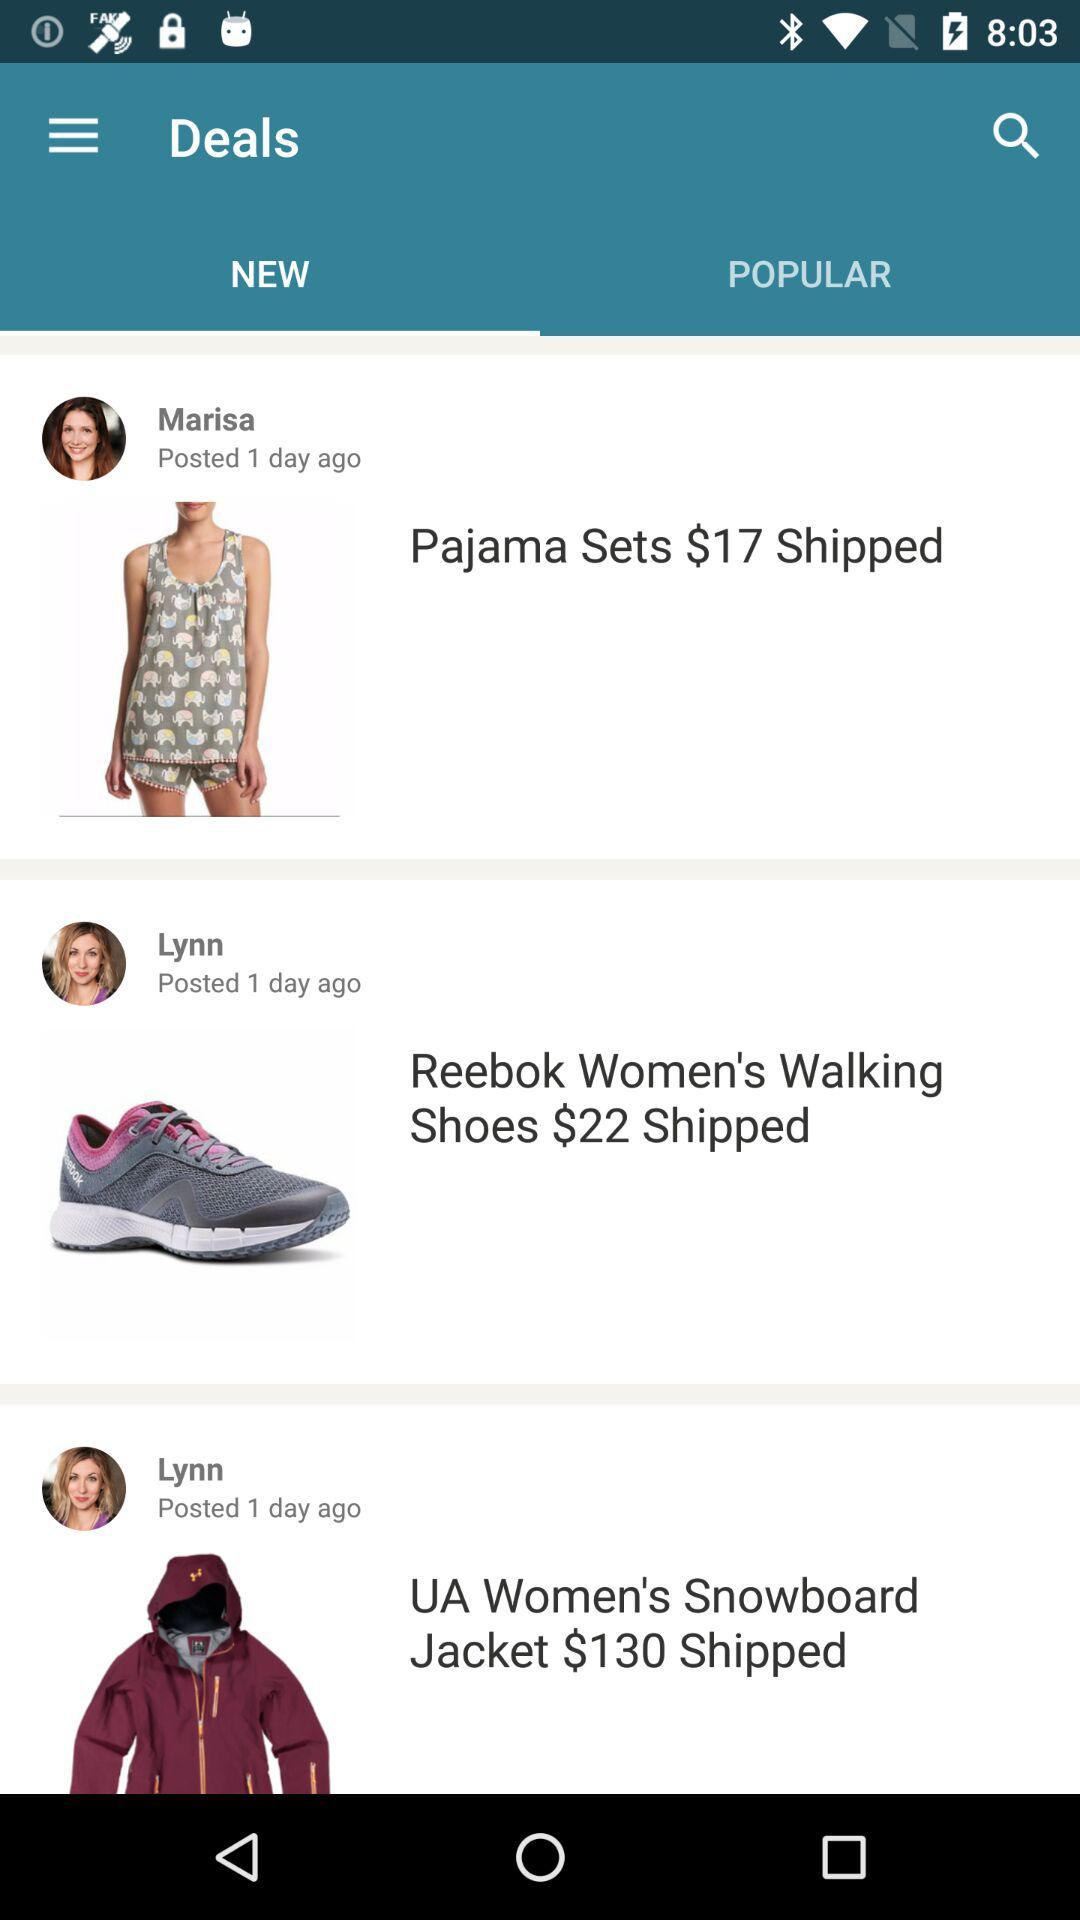What is the status of the "UA Women's Snowboard Jacket"? The status of the "UA Women's Snowboard Jacket" is shipped. 